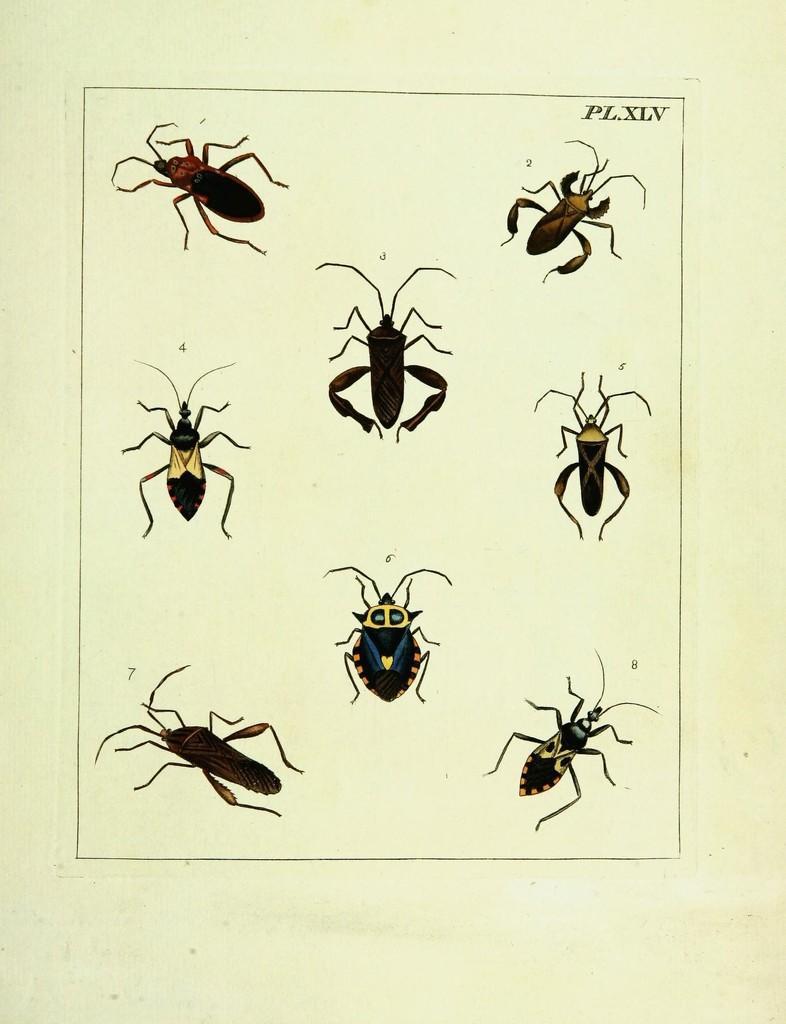In one or two sentences, can you explain what this image depicts? In this picture, we see different types of insects are drawn on the paper. This paper is in white color. 